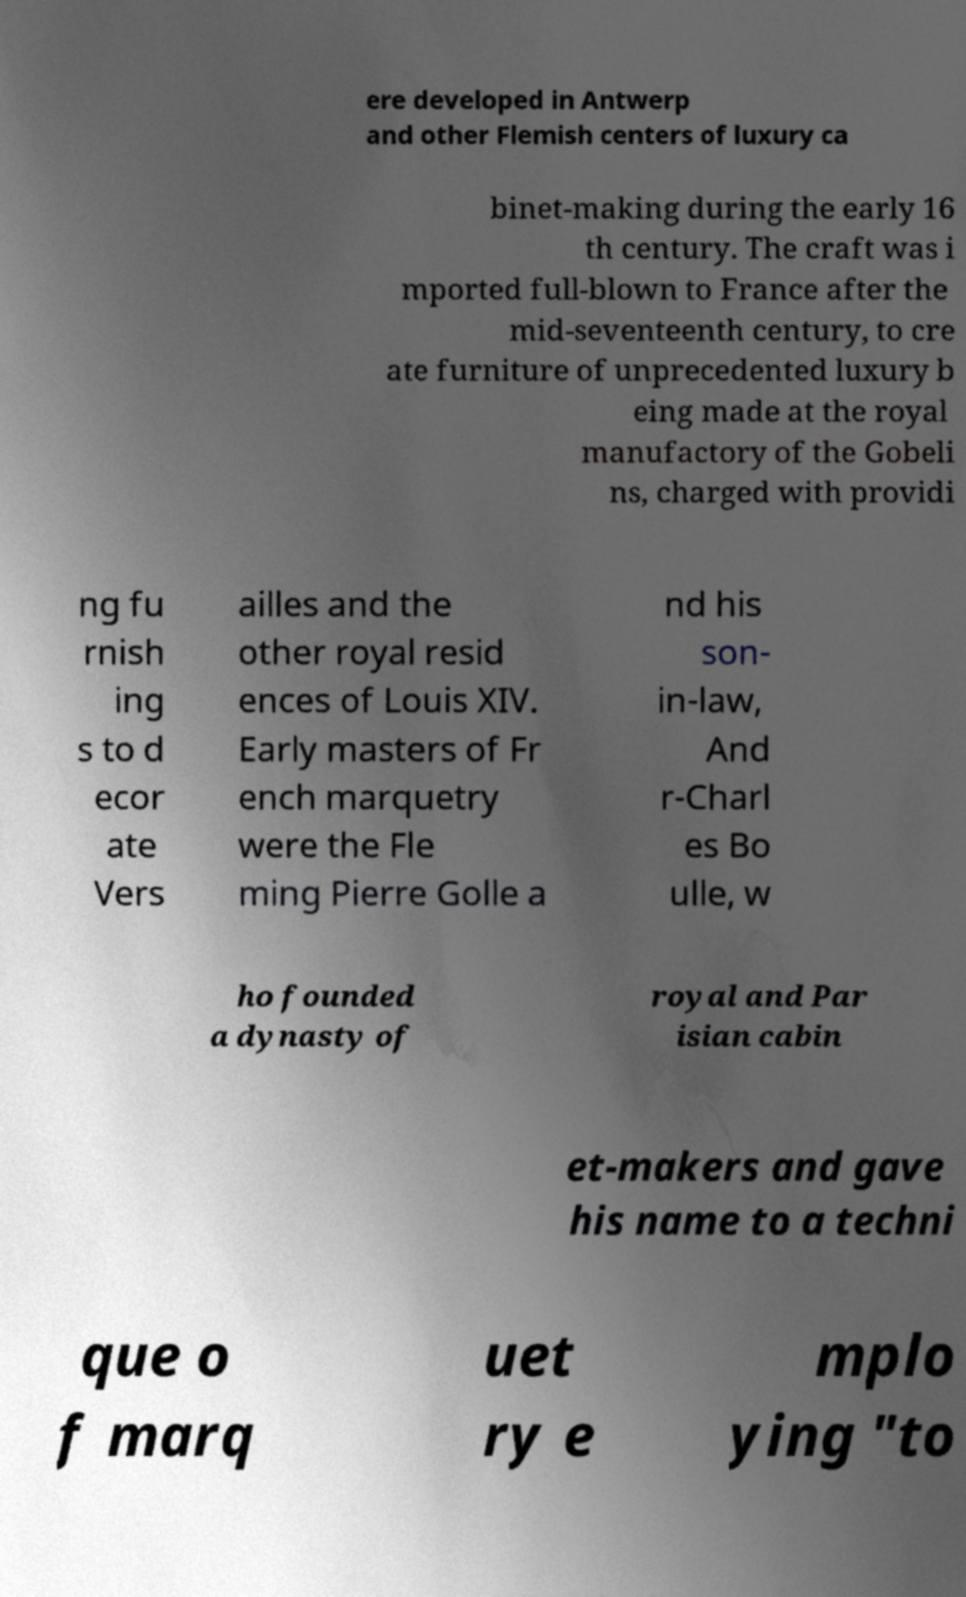Could you assist in decoding the text presented in this image and type it out clearly? ere developed in Antwerp and other Flemish centers of luxury ca binet-making during the early 16 th century. The craft was i mported full-blown to France after the mid-seventeenth century, to cre ate furniture of unprecedented luxury b eing made at the royal manufactory of the Gobeli ns, charged with providi ng fu rnish ing s to d ecor ate Vers ailles and the other royal resid ences of Louis XIV. Early masters of Fr ench marquetry were the Fle ming Pierre Golle a nd his son- in-law, And r-Charl es Bo ulle, w ho founded a dynasty of royal and Par isian cabin et-makers and gave his name to a techni que o f marq uet ry e mplo ying "to 